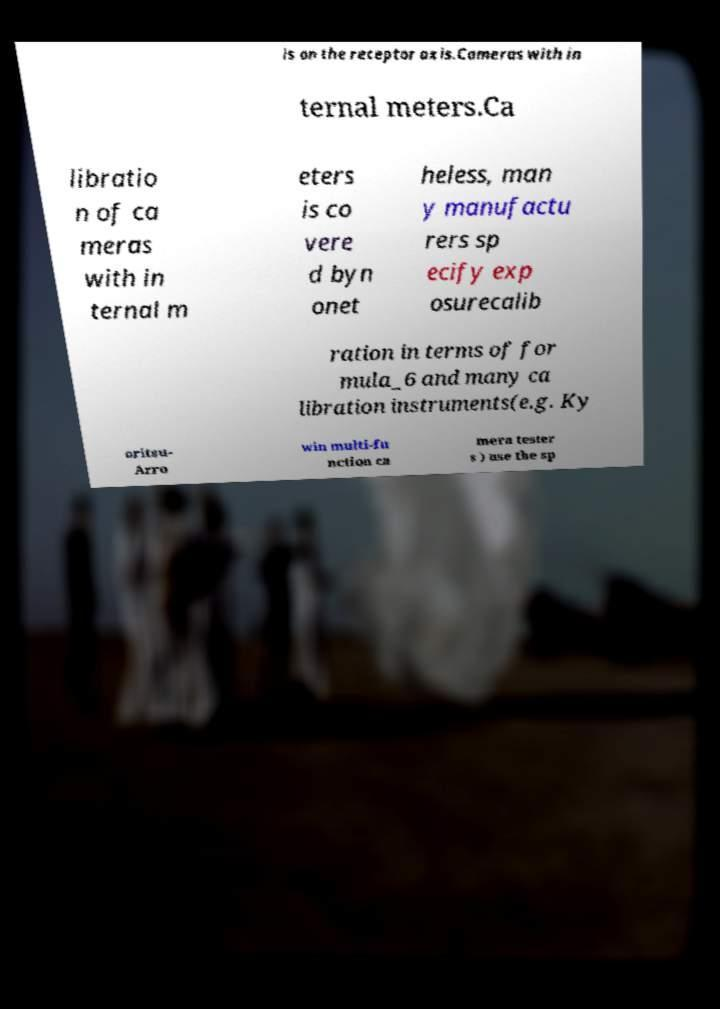There's text embedded in this image that I need extracted. Can you transcribe it verbatim? is on the receptor axis.Cameras with in ternal meters.Ca libratio n of ca meras with in ternal m eters is co vere d byn onet heless, man y manufactu rers sp ecify exp osurecalib ration in terms of for mula_6 and many ca libration instruments(e.g. Ky oritsu- Arro win multi-fu nction ca mera tester s ) use the sp 